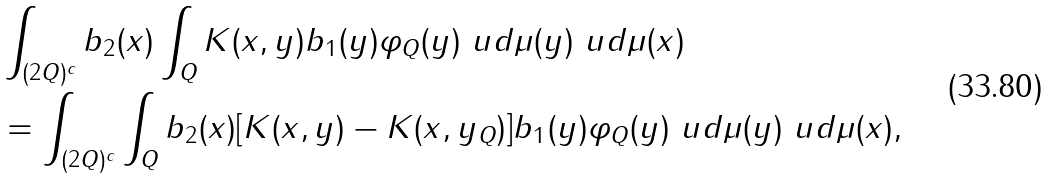<formula> <loc_0><loc_0><loc_500><loc_500>& \int _ { ( 2 Q ) ^ { c } } b _ { 2 } ( x ) \int _ { Q } K ( x , y ) b _ { 1 } ( y ) \varphi _ { Q } ( y ) \ u d \mu ( y ) \ u d \mu ( x ) \\ & = \int _ { ( 2 Q ) ^ { c } } \int _ { Q } b _ { 2 } ( x ) [ K ( x , y ) - K ( x , y _ { Q } ) ] b _ { 1 } ( y ) \varphi _ { Q } ( y ) \ u d \mu ( y ) \ u d \mu ( x ) ,</formula> 